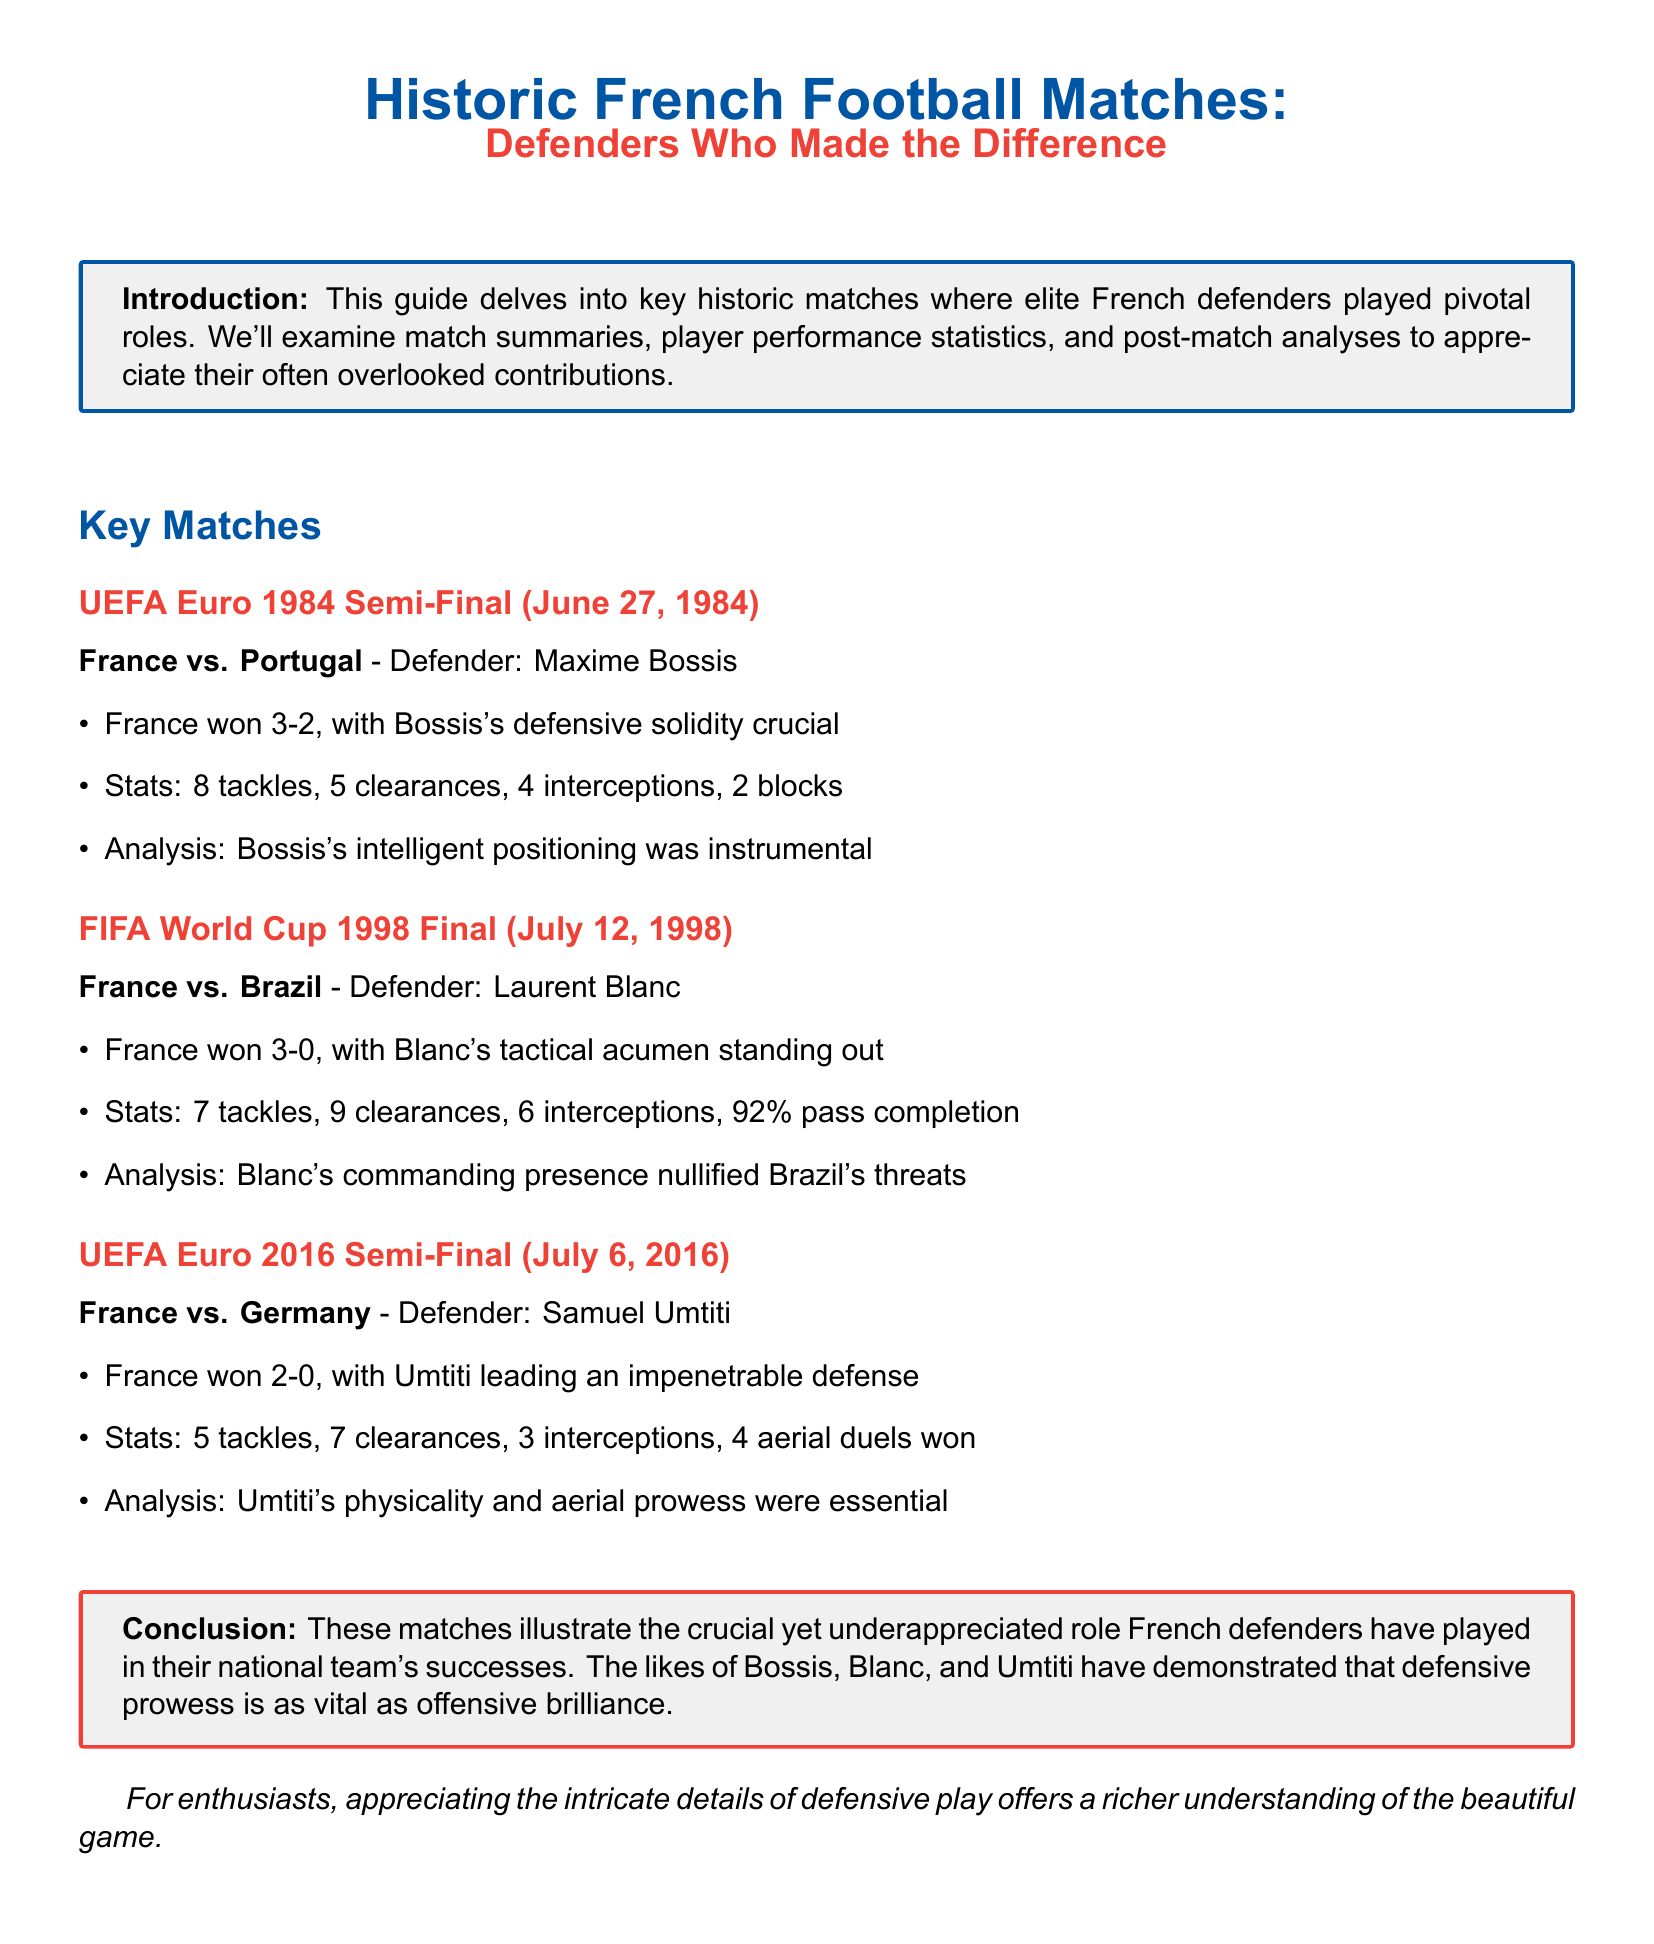What was the score of the UEFA Euro 1984 Semi-Final? The match summary indicates that France won against Portugal with a score of 3-2.
Answer: 3-2 Who was the defender for France in the FIFA World Cup 1998 Final? The document states that Laurent Blanc played as the defender for France during the final match.
Answer: Laurent Blanc How many tackles did Maxime Bossis record in the UEFA Euro 1984 Semi-Final? The statistics for Bossis show that he recorded 8 tackles during the match.
Answer: 8 What is highlighted as crucial for Umtiti's performance in the UEFA Euro 2016 Semi-Final? The analysis emphasizes that Umtiti's physicality and aerial prowess were essential to the team's success.
Answer: Physicality and aerial prowess What date did the UEFA Euro 2016 Semi-Final take place? The document specifies that the match occurred on July 6, 2016.
Answer: July 6, 2016 How many clearances did Laurent Blanc have in the FIFA World Cup 1998 Final? The performance statistics indicate that Blanc had 9 clearances in the match.
Answer: 9 In what section is the conclusion found? The document organizes content into sections, and the conclusion can be found in the section labeled "Conclusion."
Answer: Conclusion What is the main focus of this guide? The introduction details that the guide focuses on key historic matches featuring underappreciated French defenders.
Answer: Underappreciated French defenders How long is the guide's document? The document consists of several sections, including match summaries and analyses, giving an extensive view on the topic.
Answer: Comprehensive 